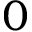<formula> <loc_0><loc_0><loc_500><loc_500>0</formula> 